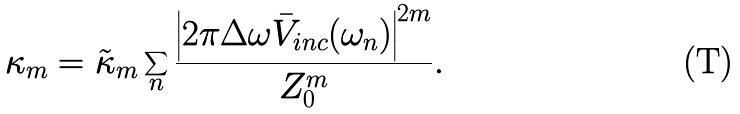<formula> <loc_0><loc_0><loc_500><loc_500>\kappa _ { m } = \tilde { \kappa } _ { m } \sum _ { n } \frac { \left | 2 \pi \Delta \omega \bar { V } _ { i n c } ( \omega _ { n } ) \right | ^ { 2 m } } { Z _ { 0 } ^ { m } } .</formula> 